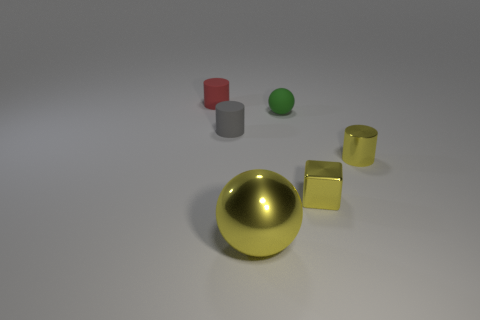Add 2 small cubes. How many objects exist? 8 Subtract all balls. How many objects are left? 4 Subtract all gray things. Subtract all tiny green spheres. How many objects are left? 4 Add 3 tiny yellow cylinders. How many tiny yellow cylinders are left? 4 Add 2 yellow matte balls. How many yellow matte balls exist? 2 Subtract 0 gray blocks. How many objects are left? 6 